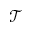<formula> <loc_0><loc_0><loc_500><loc_500>\mathcal { T }</formula> 